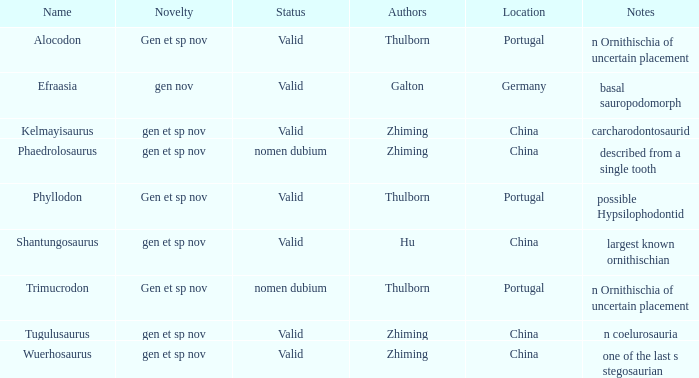What dinosaur species was unearthed in china and is characterized by being defined through a single tooth? Phaedrolosaurus. 